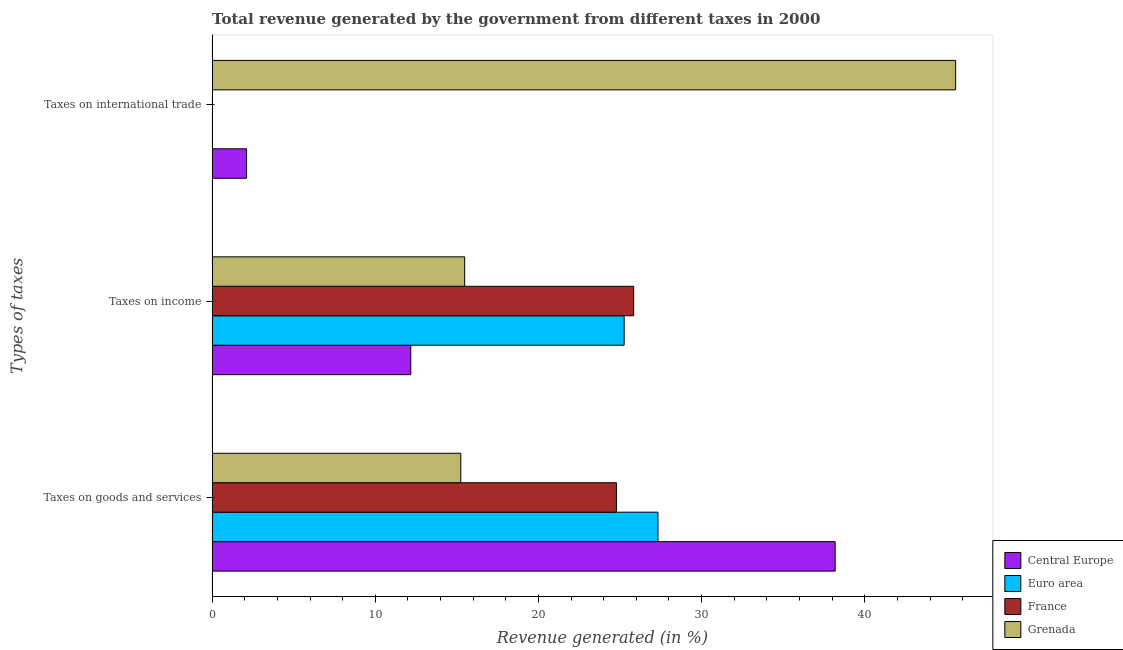How many groups of bars are there?
Ensure brevity in your answer.  3. Are the number of bars per tick equal to the number of legend labels?
Offer a very short reply. Yes. How many bars are there on the 2nd tick from the bottom?
Your answer should be very brief. 4. What is the label of the 3rd group of bars from the top?
Make the answer very short. Taxes on goods and services. What is the percentage of revenue generated by taxes on income in Euro area?
Your answer should be compact. 25.25. Across all countries, what is the maximum percentage of revenue generated by taxes on goods and services?
Give a very brief answer. 38.19. Across all countries, what is the minimum percentage of revenue generated by tax on international trade?
Your answer should be very brief. 0. In which country was the percentage of revenue generated by taxes on goods and services minimum?
Offer a very short reply. Grenada. What is the total percentage of revenue generated by taxes on goods and services in the graph?
Your answer should be very brief. 105.53. What is the difference between the percentage of revenue generated by taxes on goods and services in France and that in Grenada?
Give a very brief answer. 9.54. What is the difference between the percentage of revenue generated by tax on international trade in Grenada and the percentage of revenue generated by taxes on goods and services in Central Europe?
Offer a terse response. 7.38. What is the average percentage of revenue generated by taxes on goods and services per country?
Provide a succinct answer. 26.38. What is the difference between the percentage of revenue generated by taxes on goods and services and percentage of revenue generated by taxes on income in Euro area?
Make the answer very short. 2.07. In how many countries, is the percentage of revenue generated by tax on international trade greater than 18 %?
Keep it short and to the point. 1. What is the ratio of the percentage of revenue generated by taxes on income in France to that in Grenada?
Your response must be concise. 1.67. What is the difference between the highest and the second highest percentage of revenue generated by taxes on income?
Your answer should be compact. 0.58. What is the difference between the highest and the lowest percentage of revenue generated by taxes on income?
Offer a very short reply. 13.66. In how many countries, is the percentage of revenue generated by taxes on goods and services greater than the average percentage of revenue generated by taxes on goods and services taken over all countries?
Provide a succinct answer. 2. Is the sum of the percentage of revenue generated by taxes on income in France and Grenada greater than the maximum percentage of revenue generated by tax on international trade across all countries?
Offer a very short reply. No. What does the 1st bar from the top in Taxes on goods and services represents?
Make the answer very short. Grenada. Is it the case that in every country, the sum of the percentage of revenue generated by taxes on goods and services and percentage of revenue generated by taxes on income is greater than the percentage of revenue generated by tax on international trade?
Make the answer very short. No. How many bars are there?
Ensure brevity in your answer.  12. How many countries are there in the graph?
Offer a terse response. 4. Does the graph contain grids?
Your response must be concise. No. Where does the legend appear in the graph?
Your answer should be very brief. Bottom right. How many legend labels are there?
Offer a very short reply. 4. What is the title of the graph?
Provide a short and direct response. Total revenue generated by the government from different taxes in 2000. Does "South Africa" appear as one of the legend labels in the graph?
Provide a short and direct response. No. What is the label or title of the X-axis?
Your response must be concise. Revenue generated (in %). What is the label or title of the Y-axis?
Ensure brevity in your answer.  Types of taxes. What is the Revenue generated (in %) in Central Europe in Taxes on goods and services?
Provide a short and direct response. 38.19. What is the Revenue generated (in %) of Euro area in Taxes on goods and services?
Offer a terse response. 27.33. What is the Revenue generated (in %) of France in Taxes on goods and services?
Offer a terse response. 24.78. What is the Revenue generated (in %) of Grenada in Taxes on goods and services?
Offer a very short reply. 15.24. What is the Revenue generated (in %) of Central Europe in Taxes on income?
Provide a short and direct response. 12.18. What is the Revenue generated (in %) in Euro area in Taxes on income?
Keep it short and to the point. 25.25. What is the Revenue generated (in %) of France in Taxes on income?
Offer a very short reply. 25.84. What is the Revenue generated (in %) in Grenada in Taxes on income?
Your answer should be compact. 15.48. What is the Revenue generated (in %) in Central Europe in Taxes on international trade?
Offer a very short reply. 2.11. What is the Revenue generated (in %) of Euro area in Taxes on international trade?
Your answer should be very brief. 0. What is the Revenue generated (in %) in France in Taxes on international trade?
Keep it short and to the point. 0. What is the Revenue generated (in %) in Grenada in Taxes on international trade?
Your response must be concise. 45.57. Across all Types of taxes, what is the maximum Revenue generated (in %) of Central Europe?
Your answer should be very brief. 38.19. Across all Types of taxes, what is the maximum Revenue generated (in %) in Euro area?
Your answer should be compact. 27.33. Across all Types of taxes, what is the maximum Revenue generated (in %) of France?
Offer a very short reply. 25.84. Across all Types of taxes, what is the maximum Revenue generated (in %) of Grenada?
Make the answer very short. 45.57. Across all Types of taxes, what is the minimum Revenue generated (in %) of Central Europe?
Ensure brevity in your answer.  2.11. Across all Types of taxes, what is the minimum Revenue generated (in %) in Euro area?
Ensure brevity in your answer.  0. Across all Types of taxes, what is the minimum Revenue generated (in %) of France?
Provide a short and direct response. 0. Across all Types of taxes, what is the minimum Revenue generated (in %) in Grenada?
Provide a succinct answer. 15.24. What is the total Revenue generated (in %) of Central Europe in the graph?
Your answer should be very brief. 52.47. What is the total Revenue generated (in %) in Euro area in the graph?
Make the answer very short. 52.58. What is the total Revenue generated (in %) of France in the graph?
Ensure brevity in your answer.  50.62. What is the total Revenue generated (in %) in Grenada in the graph?
Offer a terse response. 76.29. What is the difference between the Revenue generated (in %) of Central Europe in Taxes on goods and services and that in Taxes on income?
Provide a short and direct response. 26.01. What is the difference between the Revenue generated (in %) in Euro area in Taxes on goods and services and that in Taxes on income?
Make the answer very short. 2.07. What is the difference between the Revenue generated (in %) in France in Taxes on goods and services and that in Taxes on income?
Offer a very short reply. -1.06. What is the difference between the Revenue generated (in %) of Grenada in Taxes on goods and services and that in Taxes on income?
Your response must be concise. -0.24. What is the difference between the Revenue generated (in %) of Central Europe in Taxes on goods and services and that in Taxes on international trade?
Offer a very short reply. 36.08. What is the difference between the Revenue generated (in %) in Euro area in Taxes on goods and services and that in Taxes on international trade?
Provide a succinct answer. 27.32. What is the difference between the Revenue generated (in %) of France in Taxes on goods and services and that in Taxes on international trade?
Provide a short and direct response. 24.78. What is the difference between the Revenue generated (in %) of Grenada in Taxes on goods and services and that in Taxes on international trade?
Your answer should be compact. -30.33. What is the difference between the Revenue generated (in %) of Central Europe in Taxes on income and that in Taxes on international trade?
Your answer should be very brief. 10.06. What is the difference between the Revenue generated (in %) of Euro area in Taxes on income and that in Taxes on international trade?
Provide a short and direct response. 25.25. What is the difference between the Revenue generated (in %) of France in Taxes on income and that in Taxes on international trade?
Offer a very short reply. 25.83. What is the difference between the Revenue generated (in %) of Grenada in Taxes on income and that in Taxes on international trade?
Ensure brevity in your answer.  -30.09. What is the difference between the Revenue generated (in %) in Central Europe in Taxes on goods and services and the Revenue generated (in %) in Euro area in Taxes on income?
Provide a short and direct response. 12.93. What is the difference between the Revenue generated (in %) of Central Europe in Taxes on goods and services and the Revenue generated (in %) of France in Taxes on income?
Ensure brevity in your answer.  12.35. What is the difference between the Revenue generated (in %) in Central Europe in Taxes on goods and services and the Revenue generated (in %) in Grenada in Taxes on income?
Make the answer very short. 22.71. What is the difference between the Revenue generated (in %) in Euro area in Taxes on goods and services and the Revenue generated (in %) in France in Taxes on income?
Offer a terse response. 1.49. What is the difference between the Revenue generated (in %) in Euro area in Taxes on goods and services and the Revenue generated (in %) in Grenada in Taxes on income?
Make the answer very short. 11.85. What is the difference between the Revenue generated (in %) of France in Taxes on goods and services and the Revenue generated (in %) of Grenada in Taxes on income?
Your answer should be compact. 9.3. What is the difference between the Revenue generated (in %) in Central Europe in Taxes on goods and services and the Revenue generated (in %) in Euro area in Taxes on international trade?
Provide a succinct answer. 38.18. What is the difference between the Revenue generated (in %) in Central Europe in Taxes on goods and services and the Revenue generated (in %) in France in Taxes on international trade?
Give a very brief answer. 38.18. What is the difference between the Revenue generated (in %) in Central Europe in Taxes on goods and services and the Revenue generated (in %) in Grenada in Taxes on international trade?
Offer a terse response. -7.38. What is the difference between the Revenue generated (in %) in Euro area in Taxes on goods and services and the Revenue generated (in %) in France in Taxes on international trade?
Offer a very short reply. 27.32. What is the difference between the Revenue generated (in %) in Euro area in Taxes on goods and services and the Revenue generated (in %) in Grenada in Taxes on international trade?
Make the answer very short. -18.24. What is the difference between the Revenue generated (in %) of France in Taxes on goods and services and the Revenue generated (in %) of Grenada in Taxes on international trade?
Keep it short and to the point. -20.79. What is the difference between the Revenue generated (in %) of Central Europe in Taxes on income and the Revenue generated (in %) of Euro area in Taxes on international trade?
Keep it short and to the point. 12.17. What is the difference between the Revenue generated (in %) of Central Europe in Taxes on income and the Revenue generated (in %) of France in Taxes on international trade?
Your answer should be compact. 12.17. What is the difference between the Revenue generated (in %) of Central Europe in Taxes on income and the Revenue generated (in %) of Grenada in Taxes on international trade?
Provide a succinct answer. -33.4. What is the difference between the Revenue generated (in %) of Euro area in Taxes on income and the Revenue generated (in %) of France in Taxes on international trade?
Your answer should be very brief. 25.25. What is the difference between the Revenue generated (in %) of Euro area in Taxes on income and the Revenue generated (in %) of Grenada in Taxes on international trade?
Offer a terse response. -20.32. What is the difference between the Revenue generated (in %) of France in Taxes on income and the Revenue generated (in %) of Grenada in Taxes on international trade?
Provide a short and direct response. -19.73. What is the average Revenue generated (in %) of Central Europe per Types of taxes?
Your answer should be very brief. 17.49. What is the average Revenue generated (in %) in Euro area per Types of taxes?
Keep it short and to the point. 17.53. What is the average Revenue generated (in %) of France per Types of taxes?
Your response must be concise. 16.87. What is the average Revenue generated (in %) in Grenada per Types of taxes?
Keep it short and to the point. 25.43. What is the difference between the Revenue generated (in %) of Central Europe and Revenue generated (in %) of Euro area in Taxes on goods and services?
Provide a succinct answer. 10.86. What is the difference between the Revenue generated (in %) in Central Europe and Revenue generated (in %) in France in Taxes on goods and services?
Offer a very short reply. 13.41. What is the difference between the Revenue generated (in %) in Central Europe and Revenue generated (in %) in Grenada in Taxes on goods and services?
Provide a succinct answer. 22.95. What is the difference between the Revenue generated (in %) in Euro area and Revenue generated (in %) in France in Taxes on goods and services?
Your answer should be compact. 2.55. What is the difference between the Revenue generated (in %) of Euro area and Revenue generated (in %) of Grenada in Taxes on goods and services?
Ensure brevity in your answer.  12.09. What is the difference between the Revenue generated (in %) of France and Revenue generated (in %) of Grenada in Taxes on goods and services?
Provide a short and direct response. 9.54. What is the difference between the Revenue generated (in %) in Central Europe and Revenue generated (in %) in Euro area in Taxes on income?
Offer a terse response. -13.08. What is the difference between the Revenue generated (in %) of Central Europe and Revenue generated (in %) of France in Taxes on income?
Offer a very short reply. -13.66. What is the difference between the Revenue generated (in %) of Central Europe and Revenue generated (in %) of Grenada in Taxes on income?
Provide a short and direct response. -3.3. What is the difference between the Revenue generated (in %) in Euro area and Revenue generated (in %) in France in Taxes on income?
Give a very brief answer. -0.58. What is the difference between the Revenue generated (in %) in Euro area and Revenue generated (in %) in Grenada in Taxes on income?
Keep it short and to the point. 9.78. What is the difference between the Revenue generated (in %) in France and Revenue generated (in %) in Grenada in Taxes on income?
Make the answer very short. 10.36. What is the difference between the Revenue generated (in %) of Central Europe and Revenue generated (in %) of Euro area in Taxes on international trade?
Offer a terse response. 2.11. What is the difference between the Revenue generated (in %) in Central Europe and Revenue generated (in %) in France in Taxes on international trade?
Give a very brief answer. 2.11. What is the difference between the Revenue generated (in %) of Central Europe and Revenue generated (in %) of Grenada in Taxes on international trade?
Your answer should be compact. -43.46. What is the difference between the Revenue generated (in %) of Euro area and Revenue generated (in %) of France in Taxes on international trade?
Keep it short and to the point. -0. What is the difference between the Revenue generated (in %) of Euro area and Revenue generated (in %) of Grenada in Taxes on international trade?
Your answer should be very brief. -45.57. What is the difference between the Revenue generated (in %) in France and Revenue generated (in %) in Grenada in Taxes on international trade?
Your response must be concise. -45.57. What is the ratio of the Revenue generated (in %) in Central Europe in Taxes on goods and services to that in Taxes on income?
Offer a very short reply. 3.14. What is the ratio of the Revenue generated (in %) of Euro area in Taxes on goods and services to that in Taxes on income?
Your answer should be compact. 1.08. What is the ratio of the Revenue generated (in %) in France in Taxes on goods and services to that in Taxes on income?
Offer a terse response. 0.96. What is the ratio of the Revenue generated (in %) of Grenada in Taxes on goods and services to that in Taxes on income?
Keep it short and to the point. 0.98. What is the ratio of the Revenue generated (in %) in Central Europe in Taxes on goods and services to that in Taxes on international trade?
Ensure brevity in your answer.  18.08. What is the ratio of the Revenue generated (in %) in Euro area in Taxes on goods and services to that in Taxes on international trade?
Your response must be concise. 1.21e+04. What is the ratio of the Revenue generated (in %) in France in Taxes on goods and services to that in Taxes on international trade?
Offer a very short reply. 8115.68. What is the ratio of the Revenue generated (in %) of Grenada in Taxes on goods and services to that in Taxes on international trade?
Give a very brief answer. 0.33. What is the ratio of the Revenue generated (in %) in Central Europe in Taxes on income to that in Taxes on international trade?
Your answer should be compact. 5.77. What is the ratio of the Revenue generated (in %) in Euro area in Taxes on income to that in Taxes on international trade?
Keep it short and to the point. 1.12e+04. What is the ratio of the Revenue generated (in %) of France in Taxes on income to that in Taxes on international trade?
Give a very brief answer. 8461.84. What is the ratio of the Revenue generated (in %) of Grenada in Taxes on income to that in Taxes on international trade?
Offer a very short reply. 0.34. What is the difference between the highest and the second highest Revenue generated (in %) of Central Europe?
Offer a terse response. 26.01. What is the difference between the highest and the second highest Revenue generated (in %) of Euro area?
Give a very brief answer. 2.07. What is the difference between the highest and the second highest Revenue generated (in %) of France?
Your answer should be very brief. 1.06. What is the difference between the highest and the second highest Revenue generated (in %) in Grenada?
Provide a short and direct response. 30.09. What is the difference between the highest and the lowest Revenue generated (in %) of Central Europe?
Give a very brief answer. 36.08. What is the difference between the highest and the lowest Revenue generated (in %) of Euro area?
Give a very brief answer. 27.32. What is the difference between the highest and the lowest Revenue generated (in %) of France?
Your response must be concise. 25.83. What is the difference between the highest and the lowest Revenue generated (in %) in Grenada?
Ensure brevity in your answer.  30.33. 